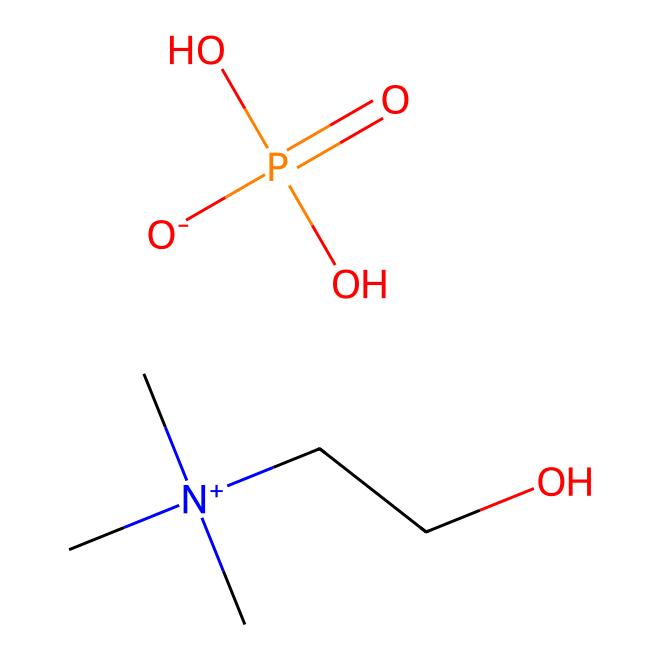What is the molecular formula of choline dihydrogen phosphate? The SMILES representation indicates the presence of carbon, nitrogen, oxygen, and phosphorus atoms. Counting each atom in the structure gives us C4, H12, N1, O4, and P1, leading to the molecular formula C4H12N1O4P1.
Answer: C4H12NO4P How many total atoms are in choline dihydrogen phosphate? By examining the molecular formula C4H12NO4P, we count the number of atoms: 4 carbon + 12 hydrogen + 1 nitrogen + 4 oxygen + 1 phosphorus = 22 total atoms.
Answer: 22 What type of chemical is choline dihydrogen phosphate classified as? Choline dihydrogen phosphate is classified as an ionic liquid, which is implied by its structure containing a quaternary nitrogen and phosphate group, characteristics common in ionic liquids.
Answer: ionic liquid How many oxygen atoms are present in choline dihydrogen phosphate? From the molecular formula C4H12NO4P, there are 4 oxygen atoms explicitly mentioned.
Answer: 4 What is the charge of the choline cation in this ionic liquid? The structure indicates a positively charged nitrogen atom is part of a quaternary ammonium group, which gives it a +1 charge.
Answer: +1 How many distinct parts does the molecule of choline dihydrogen phosphate have? Analyzing the components, we see the molecule consists of a quaternary ammonium part (choline) and a phosphate part, leading to a total of 2 distinct parts.
Answer: 2 What property of choline dihydrogen phosphate contributes to its use in biodegradable electronics? The presence of the phosphate functionality in combination with the ionic nature of the structure allows for high ionic conductivity and compatibility with biological systems, making it suitable for biodegradable applications.
Answer: high ionic conductivity 